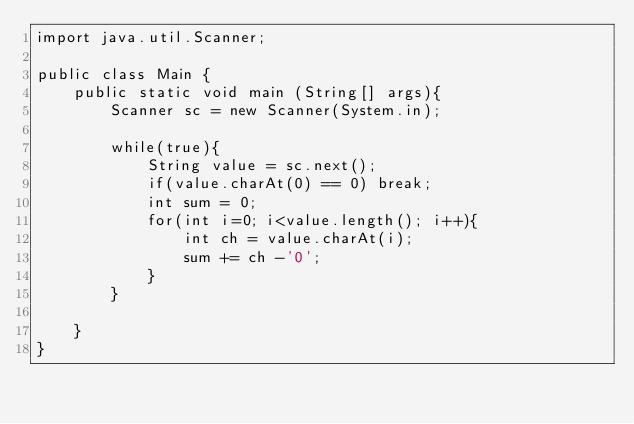Convert code to text. <code><loc_0><loc_0><loc_500><loc_500><_Java_>import java.util.Scanner;

public class Main {
	public static void main (String[] args){
		Scanner sc = new Scanner(System.in);

		while(true){
			String value = sc.next();
			if(value.charAt(0) == 0) break;
			int sum = 0;
			for(int i=0; i<value.length(); i++){
				int ch = value.charAt(i);
				sum += ch -'0';
			}
		}

	}
}</code> 